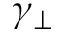<formula> <loc_0><loc_0><loc_500><loc_500>\gamma _ { \perp }</formula> 